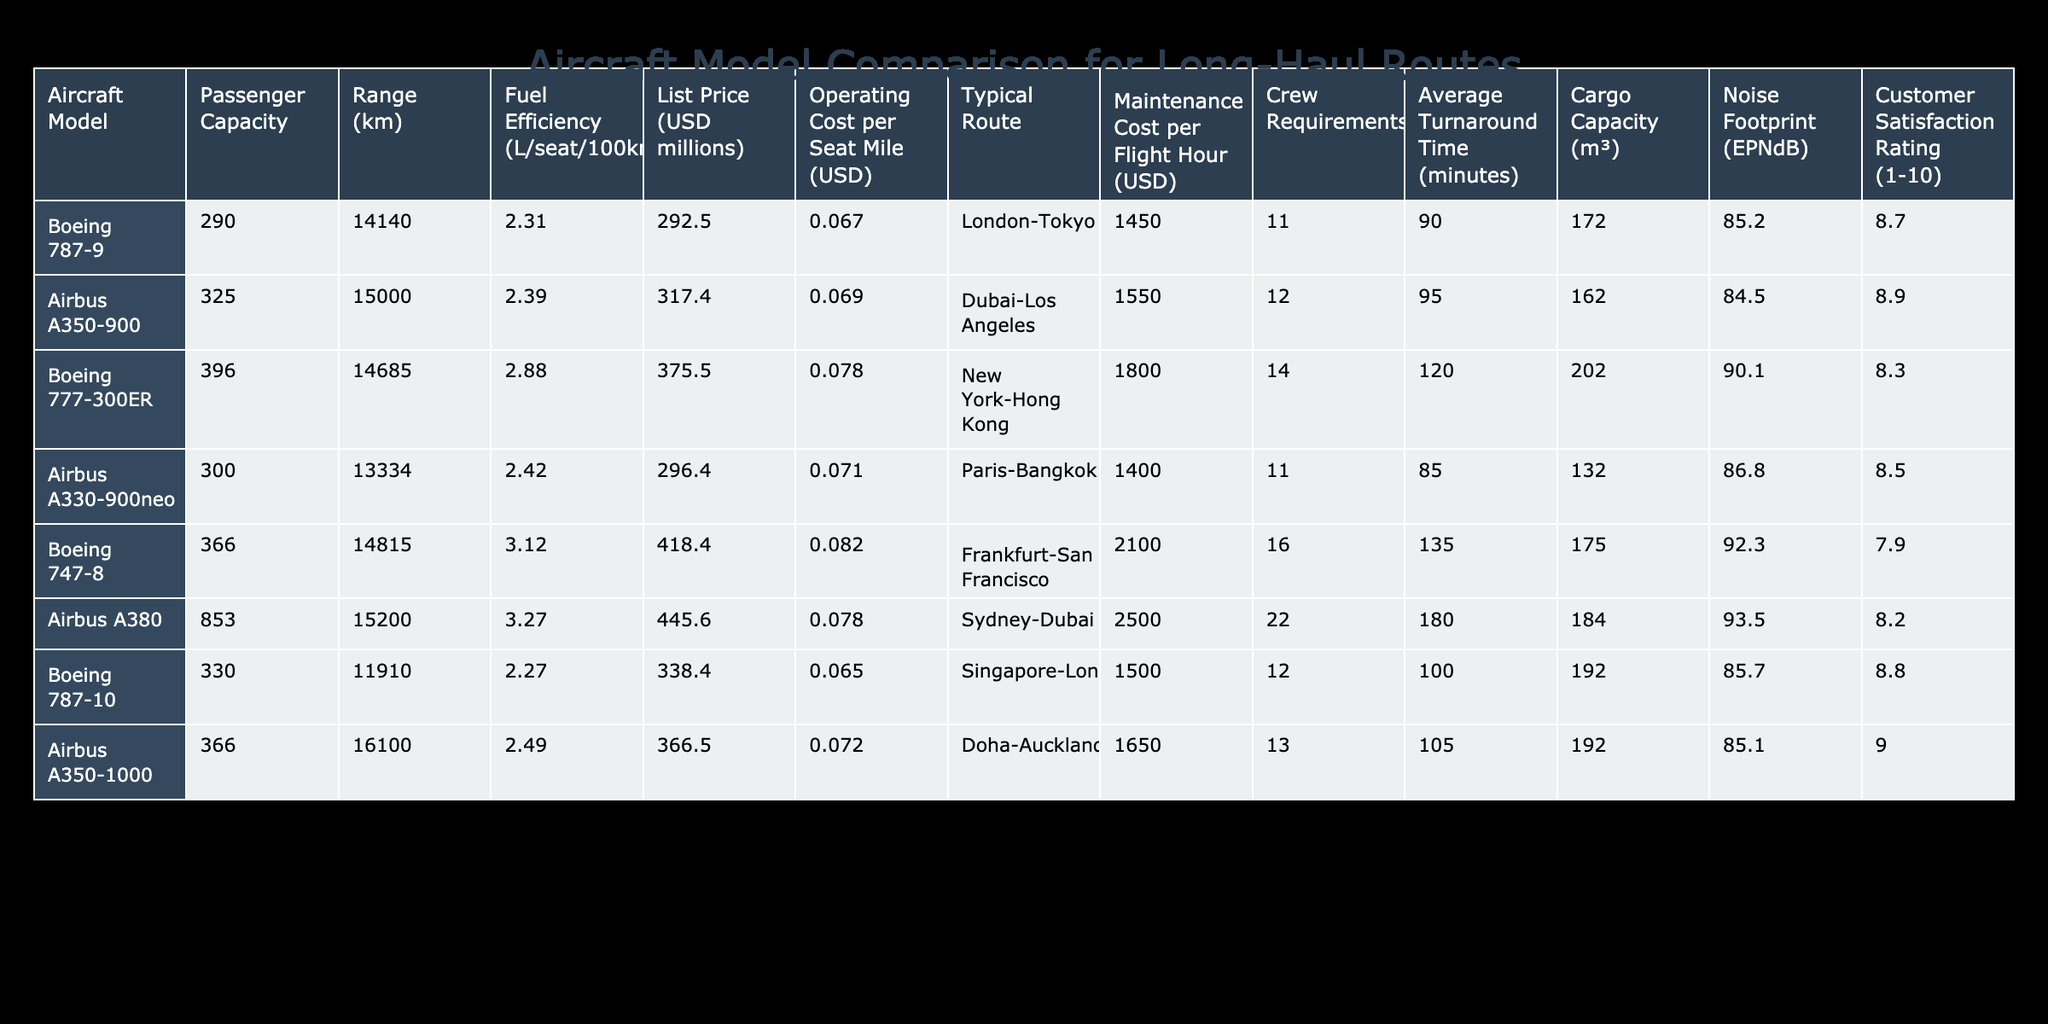What is the passenger capacity of the Airbus A350-900? Referring to the table, the Airbus A350-900 has a passenger capacity listed as 325.
Answer: 325 Which aircraft has the lowest fuel efficiency? To find the lowest fuel efficiency, we compare the fuel efficiency values across all aircraft models. The Boeing 777-300ER has a fuel efficiency of 2.88 L/seat/100km, which is the highest among the values listed, indicating it is the lowest fuel efficient option in this comparison.
Answer: Boeing 777-300ER What is the average cargo capacity of the listed aircraft? To calculate the average cargo capacity, we first sum the cargo capacities: (172 + 162 + 202 + 132 + 175 + 184 + 192 + 192) = 1317. There are 8 aircraft, so the average is 1317/8 = 164.625.
Answer: 164.6 Is the Boeing 747-8 more expensive than the Airbus A380? The list price of the Boeing 747-8 is 418.4 million USD, while the Airbus A380's list price is 445.6 million USD. Since 418.4 million is less than 445.6 million, the statement is false.
Answer: No Which aircraft has the highest customer satisfaction rating, and what is that rating? We can determine the aircraft with the highest customer satisfaction rating by comparing the ratings listed. The Airbus A350-1000 has a rating of 9.0, the highest among the entries in the table.
Answer: Airbus A350-1000, 9.0 What is the total operating cost per seat mile for the Airbus A330-900neo and the Boeing 787-10? The operating cost per seat mile for the Airbus A330-900neo is 0.071 USD and for the Boeing 787-10 it is 0.065 USD. Adding these two values gives us: 0.071 + 0.065 = 0.136 USD.
Answer: 0.136 Does the Boeing 787-9 have a higher maintenance cost per flight hour than the Boeing 777-300ER? The Boeing 787-9 has a maintenance cost per flight hour of 1450 USD, while the Boeing 777-300ER has a maintenance cost of 1800 USD. Since 1450 is less than 1800, the statement is false.
Answer: No Which aircraft has the shortest average turnaround time? By comparing the average turnaround times of all aircraft, we find the Boeing 787-10 has an average turnaround time of 100 minutes, which is the shortest in the table.
Answer: Boeing 787-10 